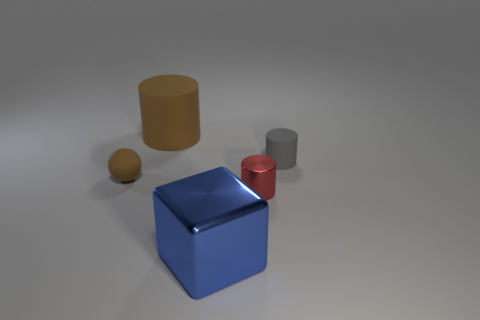Add 4 red metallic things. How many objects exist? 9 Subtract all cylinders. How many objects are left? 2 Subtract all purple metal cylinders. Subtract all big metal objects. How many objects are left? 4 Add 4 brown matte things. How many brown matte things are left? 6 Add 1 tiny red metallic objects. How many tiny red metallic objects exist? 2 Subtract 1 blue cubes. How many objects are left? 4 